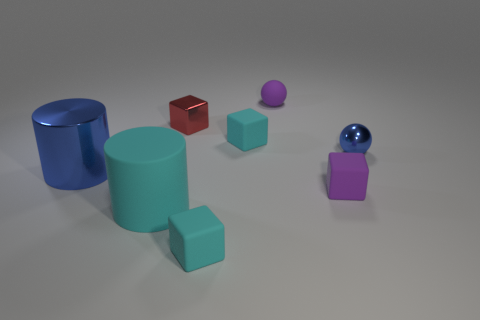Is the size of the purple object that is in front of the big shiny cylinder the same as the ball in front of the tiny red shiny cube?
Offer a terse response. Yes. What is the size of the matte object that is the same shape as the small blue metal object?
Give a very brief answer. Small. Is the number of matte spheres that are in front of the big rubber cylinder greater than the number of tiny matte spheres that are in front of the small red cube?
Keep it short and to the point. No. What material is the thing that is left of the red block and on the right side of the large blue thing?
Ensure brevity in your answer.  Rubber. There is another thing that is the same shape as the big cyan object; what is its color?
Keep it short and to the point. Blue. What size is the rubber cylinder?
Keep it short and to the point. Large. There is a small rubber block behind the large blue shiny thing that is behind the big cyan matte thing; what color is it?
Your response must be concise. Cyan. What number of objects are behind the small purple rubber block and right of the big cyan matte cylinder?
Ensure brevity in your answer.  4. Are there more blocks than tiny red metallic things?
Your response must be concise. Yes. What material is the small blue sphere?
Provide a succinct answer. Metal. 